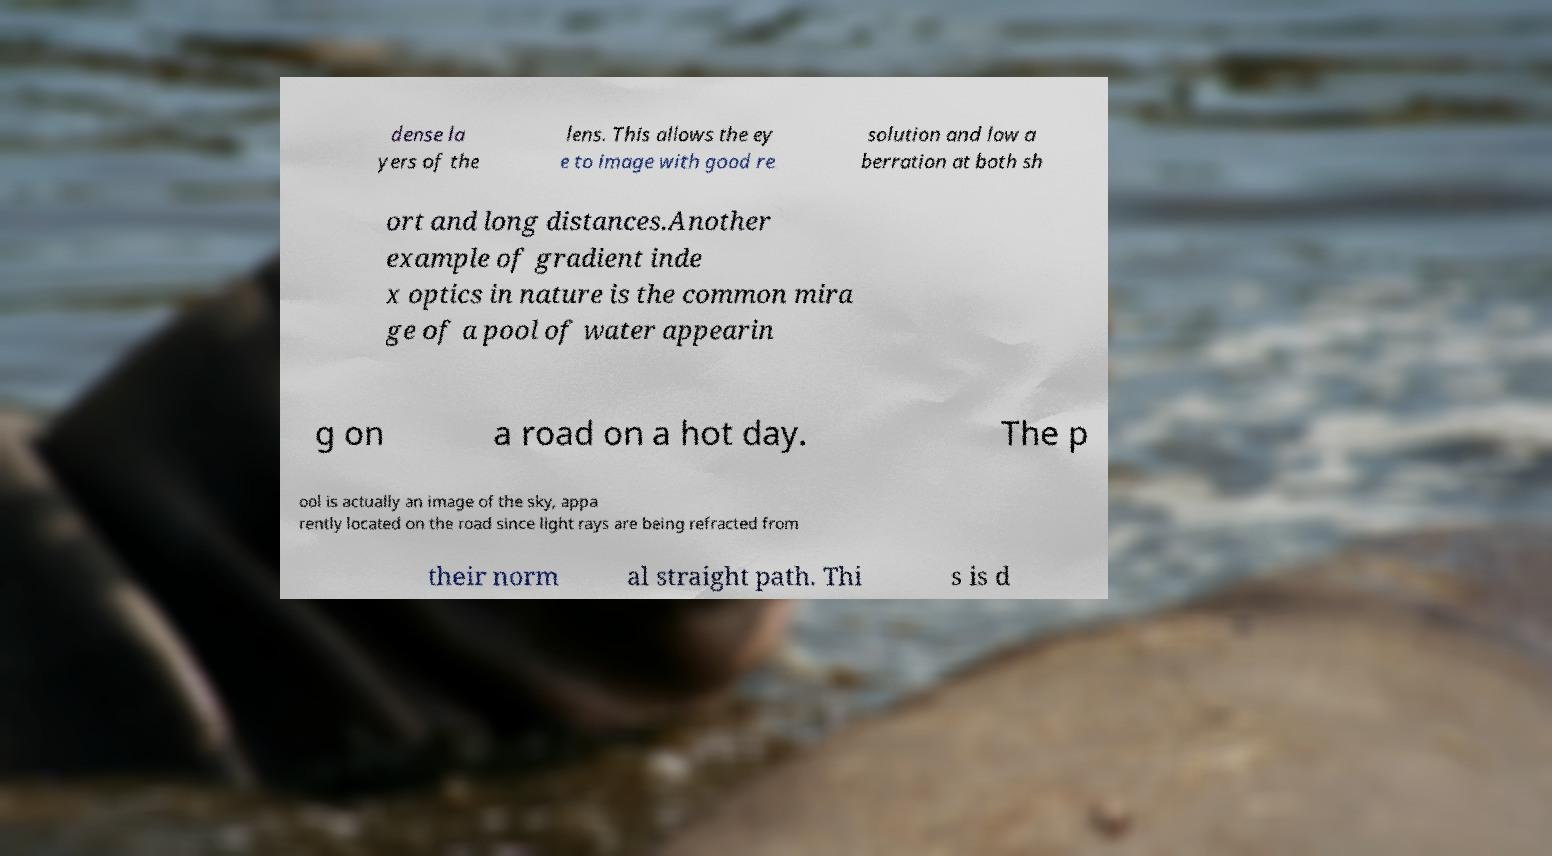Could you extract and type out the text from this image? dense la yers of the lens. This allows the ey e to image with good re solution and low a berration at both sh ort and long distances.Another example of gradient inde x optics in nature is the common mira ge of a pool of water appearin g on a road on a hot day. The p ool is actually an image of the sky, appa rently located on the road since light rays are being refracted from their norm al straight path. Thi s is d 